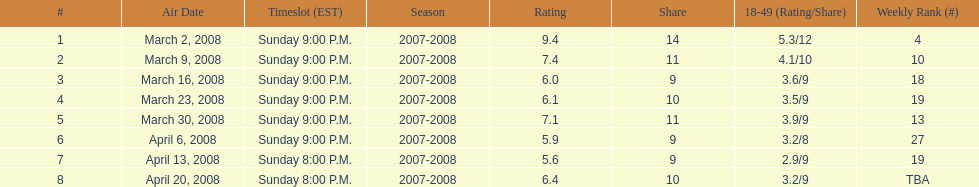Did the season finish at an earlier or later timeslot? Earlier. 